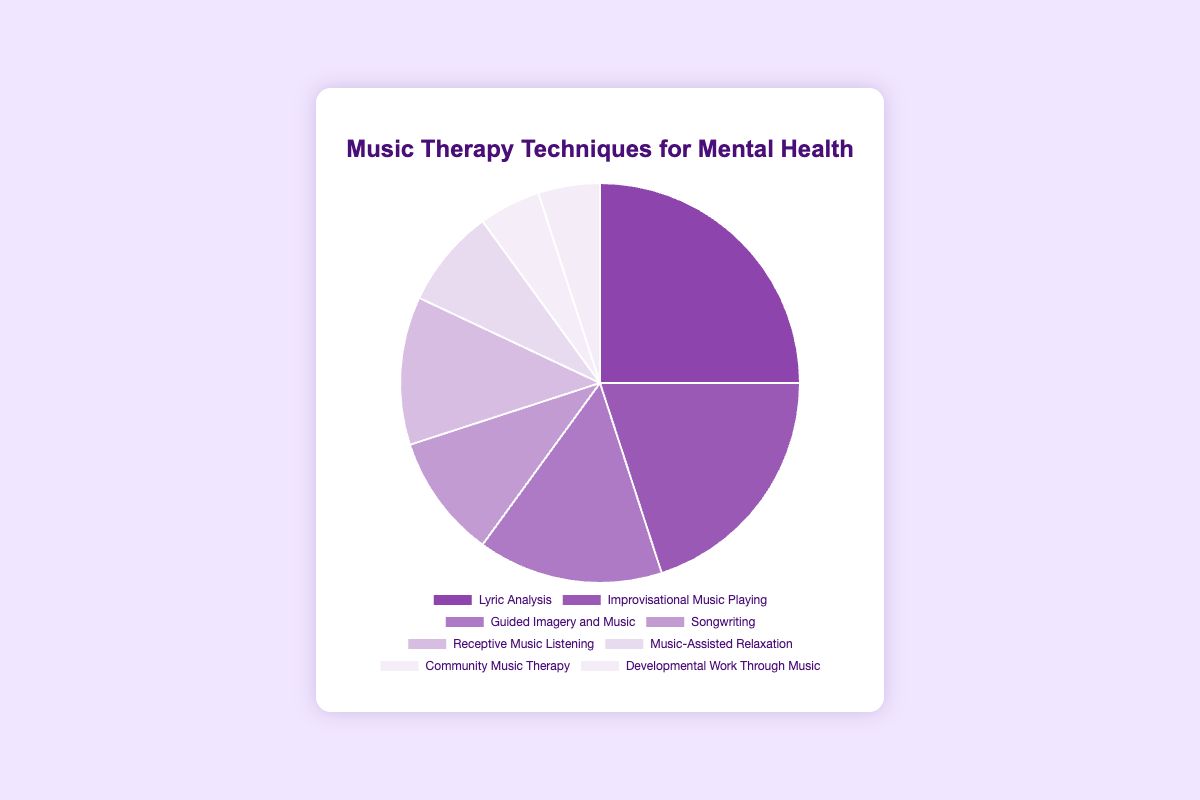What's the proportion of "Lyric Analysis" compared to "Songwriting"? "Lyric Analysis" has a 25% proportion and "Songwriting" has a 10% proportion. Subtract "Songwriting" proportion from "Lyric Analysis" proportion: 25 - 10 = 15
Answer: 15% Which technique is used the least frequently? The two techniques with the smallest proportions are "Community Music Therapy" and "Developmental Work Through Music," both at 5%. These are the least frequently used techniques.
Answer: Community Music Therapy, Developmental Work Through Music What is the total proportion of "Receptive Music Listening" and "Music-Assisted Relaxation"? "Receptive Music Listening" has a proportion of 12%, and "Music-Assisted Relaxation" has a proportion of 8%. Add these two proportions together: 12 + 8 = 20
Answer: 20% How much higher is the proportion of "Improvisational Music Playing" compared to "Guided Imagery and Music"? "Improvisational Music Playing" has a proportion of 20%, and "Guided Imagery and Music" has a proportion of 15%. Subtract the proportion of "Guided Imagery and Music" from that of "Improvisational Music Playing": 20 - 15 = 5
Answer: 5% What is the average proportion of all listed music therapy techniques? Add the proportions of all techniques: 25 + 20 + 15 + 10 + 12 + 8 + 5 + 5 = 100. Divide by the number of techniques (8): 100 / 8 = 12.5
Answer: 12.5% Which technique has the second highest proportion after "Lyric Analysis"? "Lyric Analysis" is the highest at 25%. The next highest is "Improvisational Music Playing" at 20%.
Answer: Improvisational Music Playing What proportion of the techniques are less than or equal to 10% each? The techniques with 10% or less are "Songwriting" (10%), "Music-Assisted Relaxation" (8%), "Community Music Therapy" (5%), and "Developmental Work Through Music" (5%). These account for 4 out of 8 techniques. 4/8 = 0.5 or 50%
Answer: 50% If "Lyric Analysis" and "Improvisational Music Playing" were combined into one category, what would be the new proportion? Add the proportions of "Lyric Analysis" (25%) and "Improvisational Music Playing" (20%): 25 + 20 = 45
Answer: 45% 